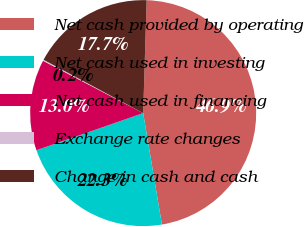Convert chart to OTSL. <chart><loc_0><loc_0><loc_500><loc_500><pie_chart><fcel>Net cash provided by operating<fcel>Net cash used in investing<fcel>Net cash used in financing<fcel>Exchange rate changes<fcel>Change in cash and cash<nl><fcel>46.86%<fcel>22.33%<fcel>12.99%<fcel>0.16%<fcel>17.66%<nl></chart> 